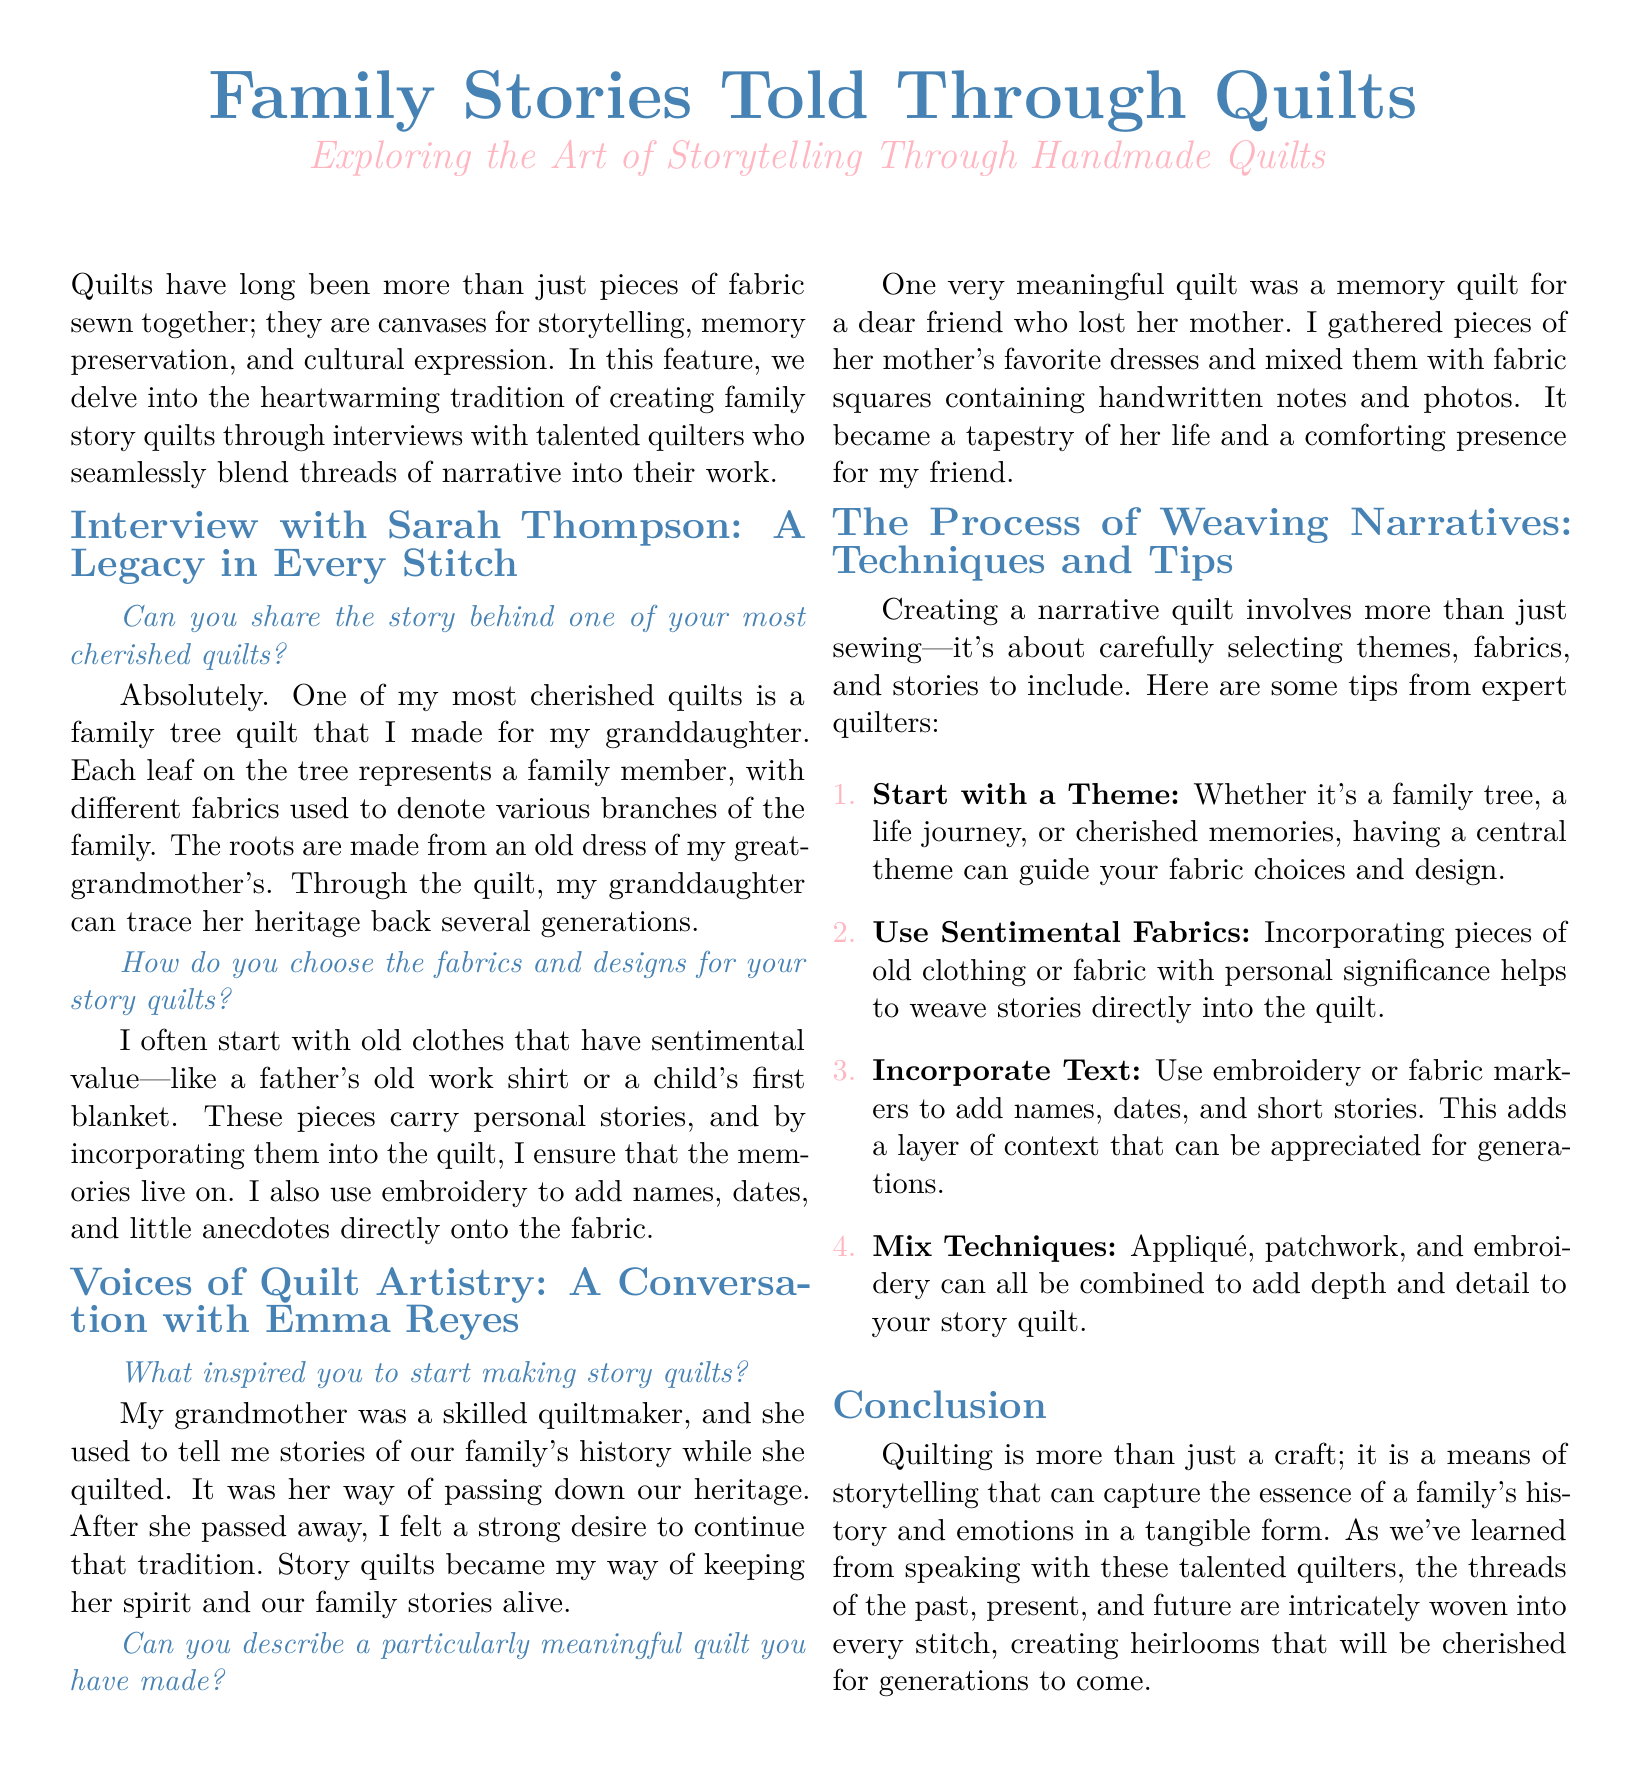What is the title of the document? The title of the document prominently displayed at the top is about family stories told through quilts.
Answer: Family Stories Told Through Quilts Who is the interviewee in the first section? The first interview features a quilter named Sarah Thompson.
Answer: Sarah Thompson What fabric represents family roots in Sarah's quilt? Sarah mentions that the roots of her family tree quilt are made from an old dress of her great-grandmother's.
Answer: Old dress What is one sentimental item Emma incorporated into her memory quilt? Emma gathered pieces of her friend's mother's favorite dresses for her memory quilt.
Answer: Favorite dresses What is one technique recommended for making narrative quilts? The document lists techniques for quilt making, including using sentimental fabrics.
Answer: Use Sentimental Fabrics How many tips are provided for creating narrative quilts? The document includes four specific tips for creating narrative quilts.
Answer: Four What is a key theme mentioned for story quilts? A central theme can guide fabric choices and design, such as a family tree.
Answer: Family tree What is the purpose of incorporating text in quilts? Adding names, dates, and stories provides context that can be appreciated for generations.
Answer: Context 